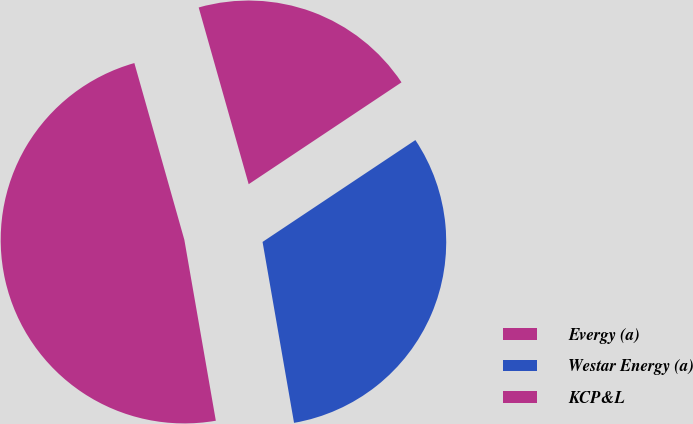<chart> <loc_0><loc_0><loc_500><loc_500><pie_chart><fcel>Evergy (a)<fcel>Westar Energy (a)<fcel>KCP&L<nl><fcel>48.35%<fcel>31.61%<fcel>20.03%<nl></chart> 